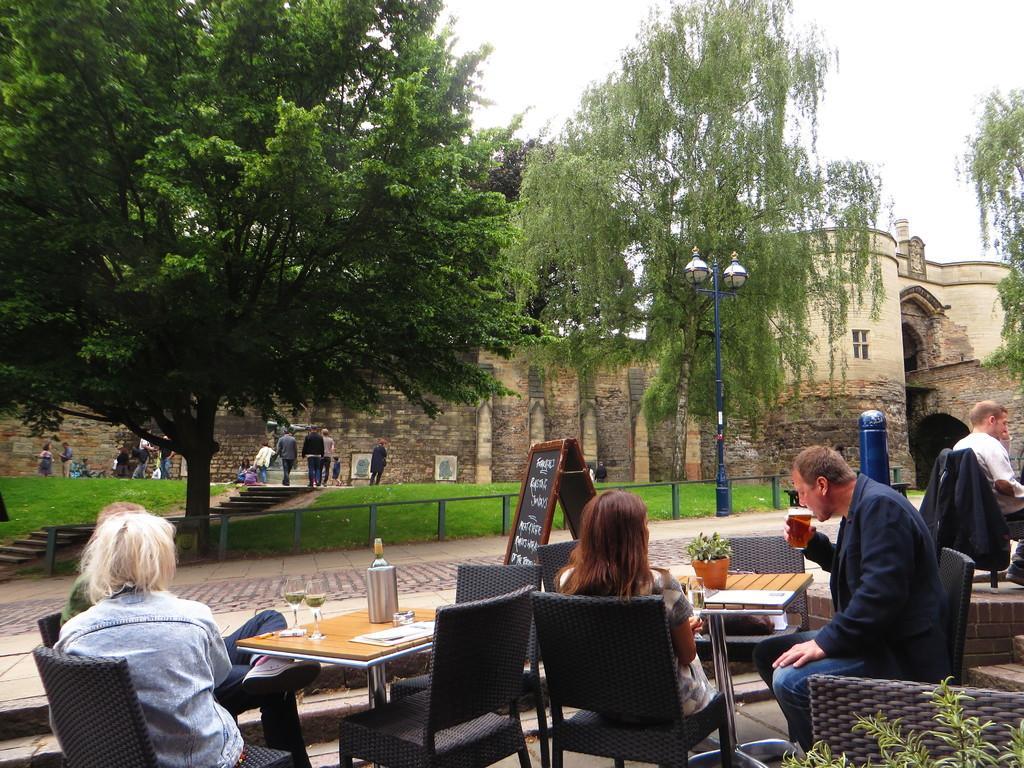In one or two sentences, can you explain what this image depicts? Persons are sitting on chairs. In-front of them there are tables, on this tablet there is a plant, paper and glasses. This man wore suit and drinking juice from this glass. Far there are plants and a building with window. This persons are walking as there is a leg movement. 